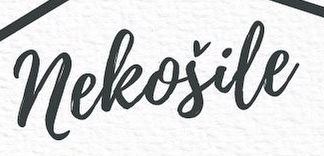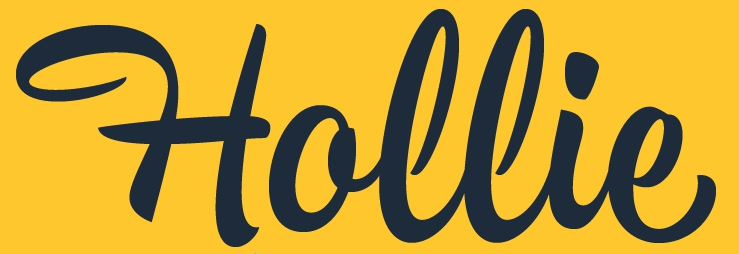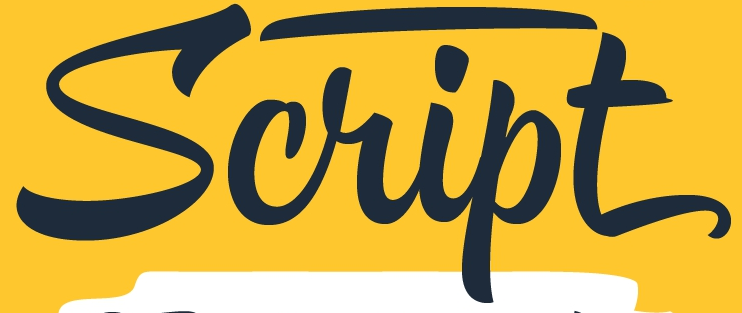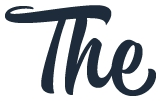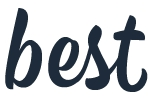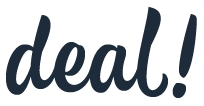What words are shown in these images in order, separated by a semicolon? neleošile; Hollie; Script; The; best; deal! 